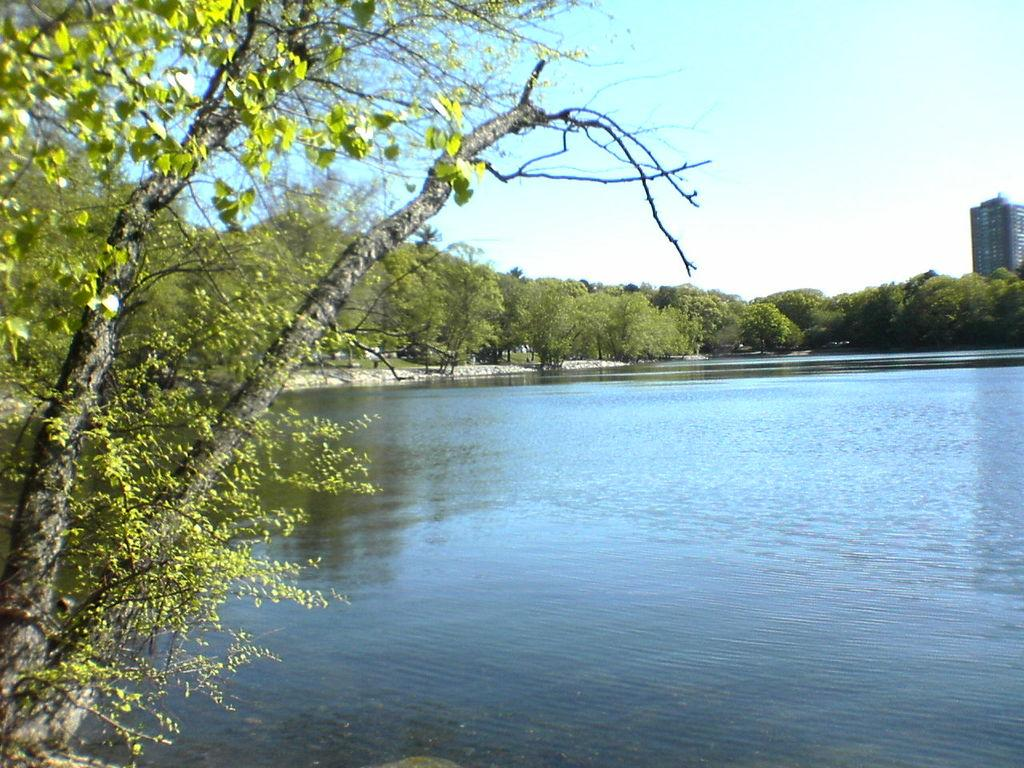What is the main feature in the middle of the picture? There is a lake in the middle of the picture. What can be seen in the background of the picture? There are trees and the sky visible in the background of the picture. What type of shame can be seen in the image? There is no shame present in the image; it is a picture of a lake, trees, and the sky. 